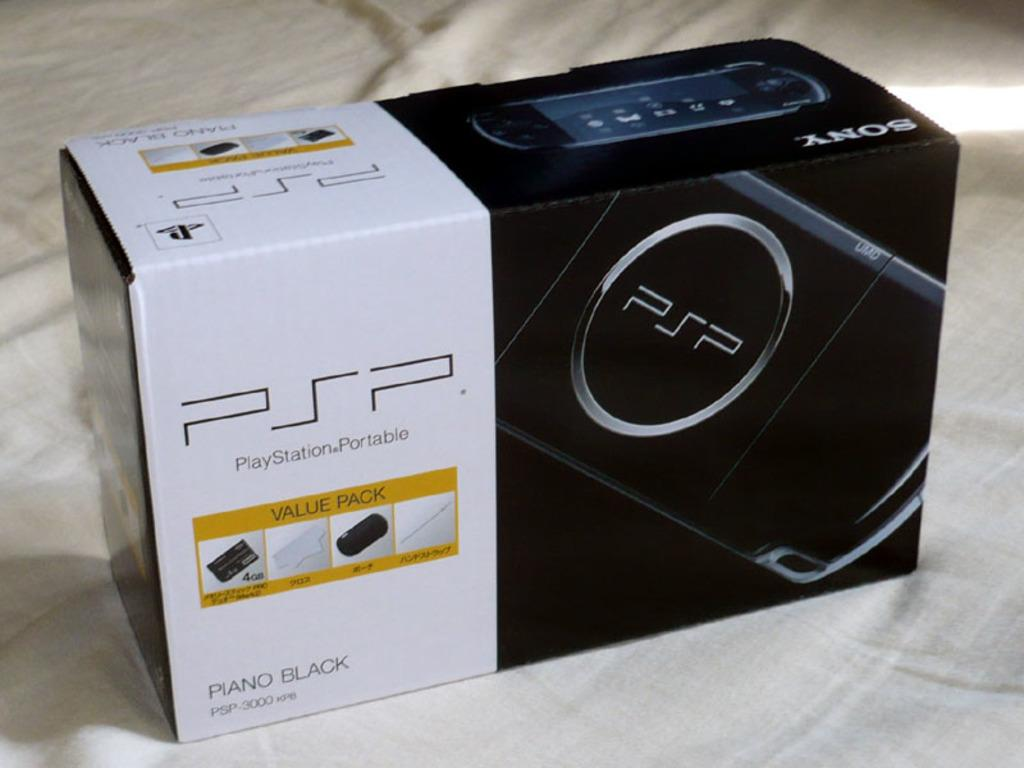<image>
Share a concise interpretation of the image provided. A black and white rectangular box holding a PSP (PlayStationPortable) in the color of piano black. 